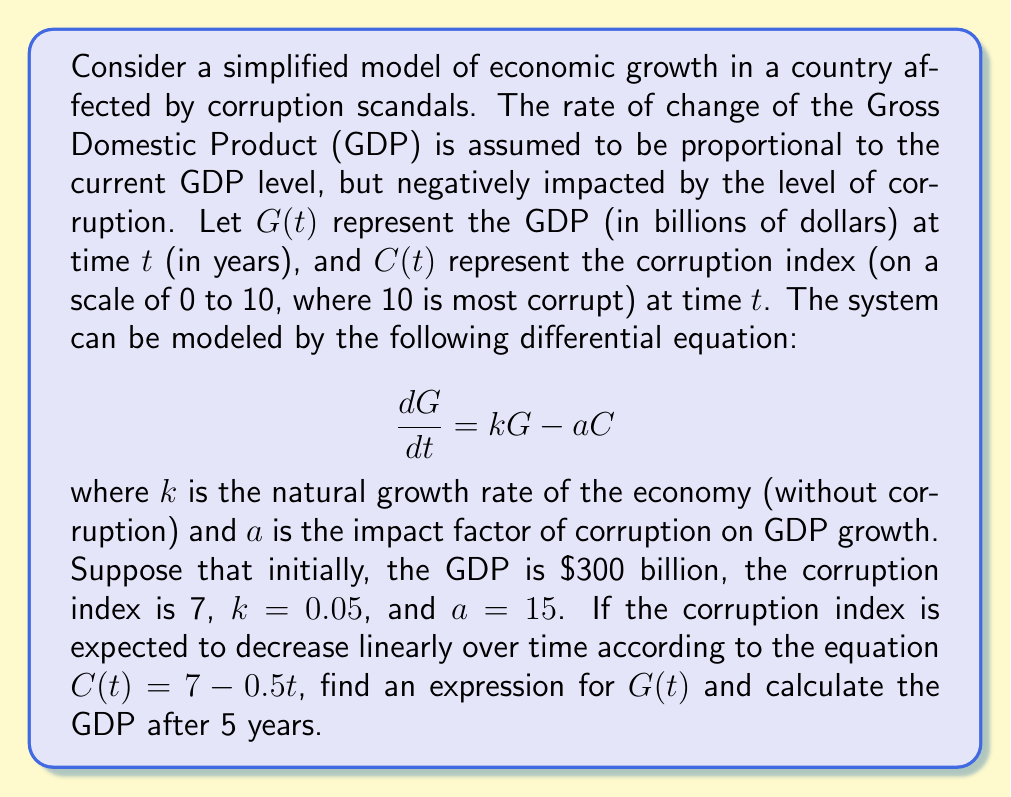Can you solve this math problem? To solve this problem, we need to follow these steps:

1) First, we substitute the given equation for $C(t)$ into our differential equation:

   $$\frac{dG}{dt} = kG - a(7 - 0.5t)$$

2) This is a first-order linear differential equation of the form:

   $$\frac{dG}{dt} + P(t)G = Q(t)$$

   where $P(t) = -k = -0.05$ and $Q(t) = a(7 - 0.5t) = 105 - 7.5t$

3) The general solution for this type of equation is:

   $$G(t) = e^{-\int P(t)dt}[\int Q(t)e^{\int P(t)dt}dt + C]$$

4) Let's solve each part:
   
   $\int P(t)dt = \int -0.05dt = -0.05t$
   
   $e^{\int P(t)dt} = e^{-0.05t}$

5) Now, we need to solve:

   $$\int Q(t)e^{\int P(t)dt}dt = \int (105 - 7.5t)e^{0.05t}dt$$

6) This integral can be solved using integration by parts. After solving, we get:

   $$(2100 - 150t)e^{0.05t} + 3000 + C_1$$

7) Therefore, the general solution is:

   $$G(t) = (2100 - 150t) + 3000e^{-0.05t} + C_2e^{-0.05t}$$

8) To find $C_2$, we use the initial condition $G(0) = 300$:

   $$300 = 2100 + 3000 + C_2$$
   $$C_2 = -4800$$

9) Thus, our particular solution is:

   $$G(t) = (2100 - 150t) + 3000e^{-0.05t} - 4800e^{-0.05t}$$
   $$G(t) = 2100 - 150t - 1800e^{-0.05t}$$

10) To find the GDP after 5 years, we calculate $G(5)$:

    $$G(5) = 2100 - 150(5) - 1800e^{-0.05(5)}$$
    $$G(5) = 2100 - 750 - 1800e^{-0.25}$$
    $$G(5) \approx 655.84$$ (rounded to 2 decimal places)
Answer: The expression for GDP over time is:

$$G(t) = 2100 - 150t - 1800e^{-0.05t}$$

The GDP after 5 years is approximately $655.84 billion. 